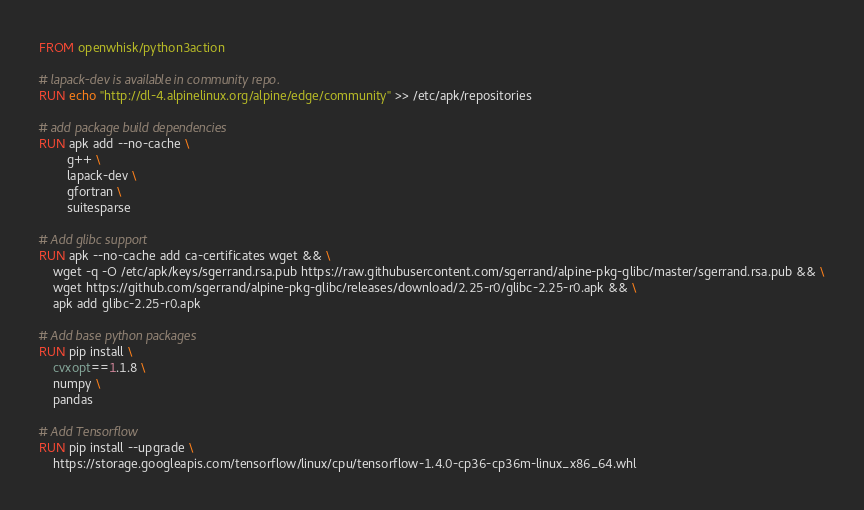Convert code to text. <code><loc_0><loc_0><loc_500><loc_500><_Dockerfile_>FROM openwhisk/python3action

# lapack-dev is available in community repo.
RUN echo "http://dl-4.alpinelinux.org/alpine/edge/community" >> /etc/apk/repositories

# add package build dependencies
RUN apk add --no-cache \
        g++ \
        lapack-dev \
        gfortran \
        suitesparse

# Add glibc support
RUN apk --no-cache add ca-certificates wget && \
    wget -q -O /etc/apk/keys/sgerrand.rsa.pub https://raw.githubusercontent.com/sgerrand/alpine-pkg-glibc/master/sgerrand.rsa.pub && \
    wget https://github.com/sgerrand/alpine-pkg-glibc/releases/download/2.25-r0/glibc-2.25-r0.apk && \
    apk add glibc-2.25-r0.apk

# Add base python packages
RUN pip install \
    cvxopt==1.1.8 \
    numpy \
    pandas

# Add Tensorflow
RUN pip install --upgrade \
    https://storage.googleapis.com/tensorflow/linux/cpu/tensorflow-1.4.0-cp36-cp36m-linux_x86_64.whl
</code> 